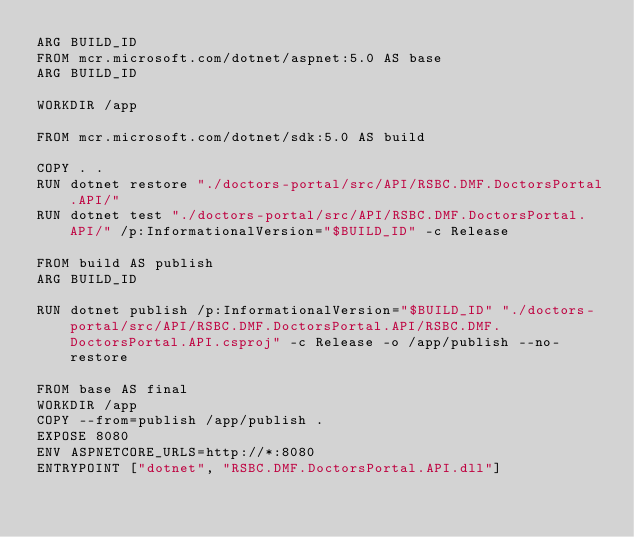<code> <loc_0><loc_0><loc_500><loc_500><_Dockerfile_>ARG BUILD_ID
FROM mcr.microsoft.com/dotnet/aspnet:5.0 AS base
ARG BUILD_ID

WORKDIR /app

FROM mcr.microsoft.com/dotnet/sdk:5.0 AS build

COPY . .
RUN dotnet restore "./doctors-portal/src/API/RSBC.DMF.DoctorsPortal.API/"
RUN dotnet test "./doctors-portal/src/API/RSBC.DMF.DoctorsPortal.API/" /p:InformationalVersion="$BUILD_ID" -c Release

FROM build AS publish
ARG BUILD_ID

RUN dotnet publish /p:InformationalVersion="$BUILD_ID" "./doctors-portal/src/API/RSBC.DMF.DoctorsPortal.API/RSBC.DMF.DoctorsPortal.API.csproj" -c Release -o /app/publish --no-restore 

FROM base AS final
WORKDIR /app
COPY --from=publish /app/publish .
EXPOSE 8080
ENV ASPNETCORE_URLS=http://*:8080
ENTRYPOINT ["dotnet", "RSBC.DMF.DoctorsPortal.API.dll"]</code> 